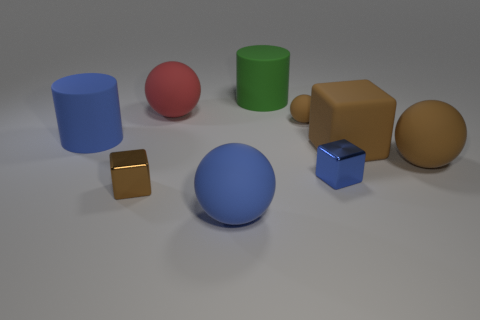Which objects in the image could easily roll? The objects that could easily roll are the spheres, one large red and the other a smaller blue.  Are there any objects with edges, and if so, how many? Yes, there are objects with edges. There are two cubes, one small gold and one larger blue, a large green cylinder, and a large brown object that resembles a capsule or pill shape. Therefore, there are four objects with distinct edges. 